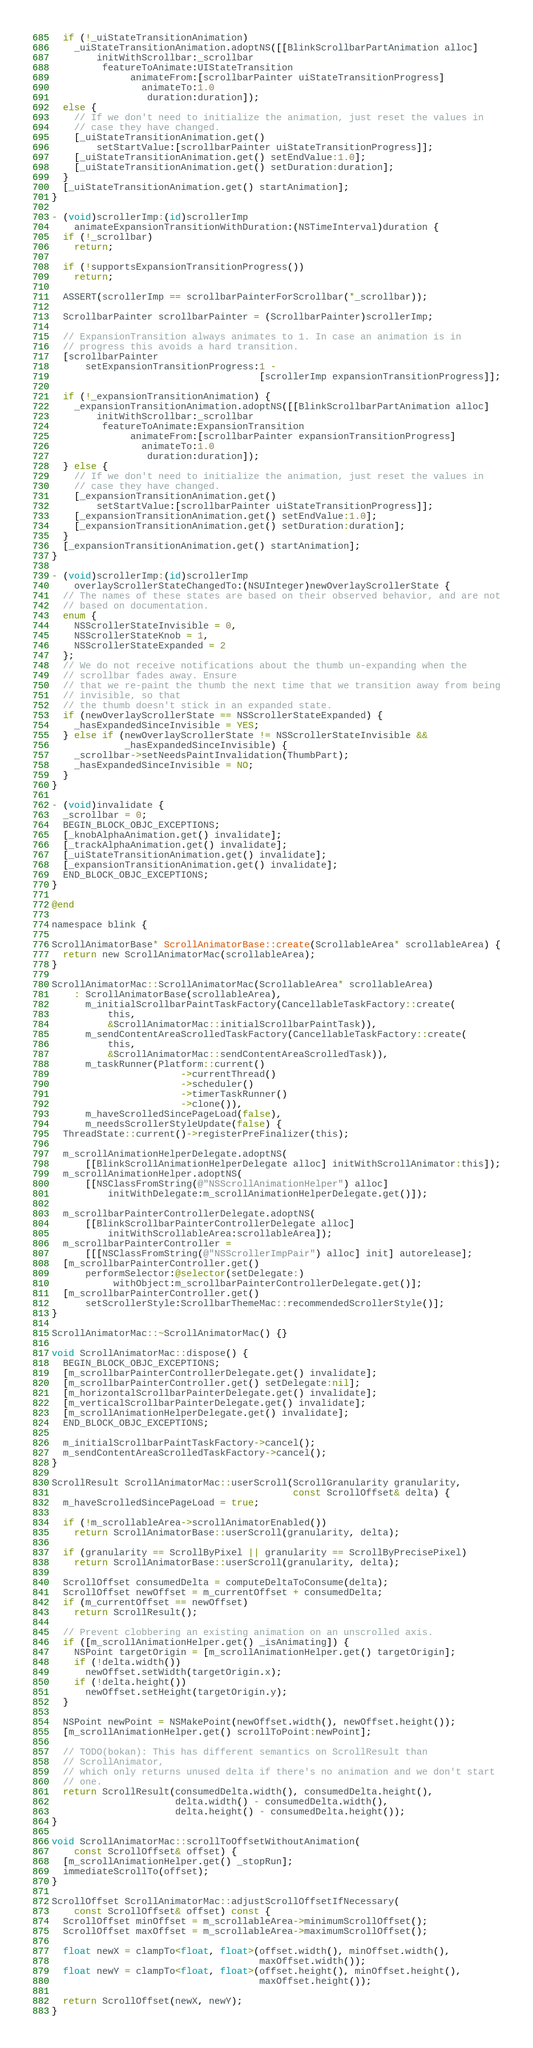<code> <loc_0><loc_0><loc_500><loc_500><_ObjectiveC_>
  if (!_uiStateTransitionAnimation)
    _uiStateTransitionAnimation.adoptNS([[BlinkScrollbarPartAnimation alloc]
        initWithScrollbar:_scrollbar
         featureToAnimate:UIStateTransition
              animateFrom:[scrollbarPainter uiStateTransitionProgress]
                animateTo:1.0
                 duration:duration]);
  else {
    // If we don't need to initialize the animation, just reset the values in
    // case they have changed.
    [_uiStateTransitionAnimation.get()
        setStartValue:[scrollbarPainter uiStateTransitionProgress]];
    [_uiStateTransitionAnimation.get() setEndValue:1.0];
    [_uiStateTransitionAnimation.get() setDuration:duration];
  }
  [_uiStateTransitionAnimation.get() startAnimation];
}

- (void)scrollerImp:(id)scrollerImp
    animateExpansionTransitionWithDuration:(NSTimeInterval)duration {
  if (!_scrollbar)
    return;

  if (!supportsExpansionTransitionProgress())
    return;

  ASSERT(scrollerImp == scrollbarPainterForScrollbar(*_scrollbar));

  ScrollbarPainter scrollbarPainter = (ScrollbarPainter)scrollerImp;

  // ExpansionTransition always animates to 1. In case an animation is in
  // progress this avoids a hard transition.
  [scrollbarPainter
      setExpansionTransitionProgress:1 -
                                     [scrollerImp expansionTransitionProgress]];

  if (!_expansionTransitionAnimation) {
    _expansionTransitionAnimation.adoptNS([[BlinkScrollbarPartAnimation alloc]
        initWithScrollbar:_scrollbar
         featureToAnimate:ExpansionTransition
              animateFrom:[scrollbarPainter expansionTransitionProgress]
                animateTo:1.0
                 duration:duration]);
  } else {
    // If we don't need to initialize the animation, just reset the values in
    // case they have changed.
    [_expansionTransitionAnimation.get()
        setStartValue:[scrollbarPainter uiStateTransitionProgress]];
    [_expansionTransitionAnimation.get() setEndValue:1.0];
    [_expansionTransitionAnimation.get() setDuration:duration];
  }
  [_expansionTransitionAnimation.get() startAnimation];
}

- (void)scrollerImp:(id)scrollerImp
    overlayScrollerStateChangedTo:(NSUInteger)newOverlayScrollerState {
  // The names of these states are based on their observed behavior, and are not
  // based on documentation.
  enum {
    NSScrollerStateInvisible = 0,
    NSScrollerStateKnob = 1,
    NSScrollerStateExpanded = 2
  };
  // We do not receive notifications about the thumb un-expanding when the
  // scrollbar fades away. Ensure
  // that we re-paint the thumb the next time that we transition away from being
  // invisible, so that
  // the thumb doesn't stick in an expanded state.
  if (newOverlayScrollerState == NSScrollerStateExpanded) {
    _hasExpandedSinceInvisible = YES;
  } else if (newOverlayScrollerState != NSScrollerStateInvisible &&
             _hasExpandedSinceInvisible) {
    _scrollbar->setNeedsPaintInvalidation(ThumbPart);
    _hasExpandedSinceInvisible = NO;
  }
}

- (void)invalidate {
  _scrollbar = 0;
  BEGIN_BLOCK_OBJC_EXCEPTIONS;
  [_knobAlphaAnimation.get() invalidate];
  [_trackAlphaAnimation.get() invalidate];
  [_uiStateTransitionAnimation.get() invalidate];
  [_expansionTransitionAnimation.get() invalidate];
  END_BLOCK_OBJC_EXCEPTIONS;
}

@end

namespace blink {

ScrollAnimatorBase* ScrollAnimatorBase::create(ScrollableArea* scrollableArea) {
  return new ScrollAnimatorMac(scrollableArea);
}

ScrollAnimatorMac::ScrollAnimatorMac(ScrollableArea* scrollableArea)
    : ScrollAnimatorBase(scrollableArea),
      m_initialScrollbarPaintTaskFactory(CancellableTaskFactory::create(
          this,
          &ScrollAnimatorMac::initialScrollbarPaintTask)),
      m_sendContentAreaScrolledTaskFactory(CancellableTaskFactory::create(
          this,
          &ScrollAnimatorMac::sendContentAreaScrolledTask)),
      m_taskRunner(Platform::current()
                       ->currentThread()
                       ->scheduler()
                       ->timerTaskRunner()
                       ->clone()),
      m_haveScrolledSincePageLoad(false),
      m_needsScrollerStyleUpdate(false) {
  ThreadState::current()->registerPreFinalizer(this);

  m_scrollAnimationHelperDelegate.adoptNS(
      [[BlinkScrollAnimationHelperDelegate alloc] initWithScrollAnimator:this]);
  m_scrollAnimationHelper.adoptNS(
      [[NSClassFromString(@"NSScrollAnimationHelper") alloc]
          initWithDelegate:m_scrollAnimationHelperDelegate.get()]);

  m_scrollbarPainterControllerDelegate.adoptNS(
      [[BlinkScrollbarPainterControllerDelegate alloc]
          initWithScrollableArea:scrollableArea]);
  m_scrollbarPainterController =
      [[[NSClassFromString(@"NSScrollerImpPair") alloc] init] autorelease];
  [m_scrollbarPainterController.get()
      performSelector:@selector(setDelegate:)
           withObject:m_scrollbarPainterControllerDelegate.get()];
  [m_scrollbarPainterController.get()
      setScrollerStyle:ScrollbarThemeMac::recommendedScrollerStyle()];
}

ScrollAnimatorMac::~ScrollAnimatorMac() {}

void ScrollAnimatorMac::dispose() {
  BEGIN_BLOCK_OBJC_EXCEPTIONS;
  [m_scrollbarPainterControllerDelegate.get() invalidate];
  [m_scrollbarPainterController.get() setDelegate:nil];
  [m_horizontalScrollbarPainterDelegate.get() invalidate];
  [m_verticalScrollbarPainterDelegate.get() invalidate];
  [m_scrollAnimationHelperDelegate.get() invalidate];
  END_BLOCK_OBJC_EXCEPTIONS;

  m_initialScrollbarPaintTaskFactory->cancel();
  m_sendContentAreaScrolledTaskFactory->cancel();
}

ScrollResult ScrollAnimatorMac::userScroll(ScrollGranularity granularity,
                                           const ScrollOffset& delta) {
  m_haveScrolledSincePageLoad = true;

  if (!m_scrollableArea->scrollAnimatorEnabled())
    return ScrollAnimatorBase::userScroll(granularity, delta);

  if (granularity == ScrollByPixel || granularity == ScrollByPrecisePixel)
    return ScrollAnimatorBase::userScroll(granularity, delta);

  ScrollOffset consumedDelta = computeDeltaToConsume(delta);
  ScrollOffset newOffset = m_currentOffset + consumedDelta;
  if (m_currentOffset == newOffset)
    return ScrollResult();

  // Prevent clobbering an existing animation on an unscrolled axis.
  if ([m_scrollAnimationHelper.get() _isAnimating]) {
    NSPoint targetOrigin = [m_scrollAnimationHelper.get() targetOrigin];
    if (!delta.width())
      newOffset.setWidth(targetOrigin.x);
    if (!delta.height())
      newOffset.setHeight(targetOrigin.y);
  }

  NSPoint newPoint = NSMakePoint(newOffset.width(), newOffset.height());
  [m_scrollAnimationHelper.get() scrollToPoint:newPoint];

  // TODO(bokan): This has different semantics on ScrollResult than
  // ScrollAnimator,
  // which only returns unused delta if there's no animation and we don't start
  // one.
  return ScrollResult(consumedDelta.width(), consumedDelta.height(),
                      delta.width() - consumedDelta.width(),
                      delta.height() - consumedDelta.height());
}

void ScrollAnimatorMac::scrollToOffsetWithoutAnimation(
    const ScrollOffset& offset) {
  [m_scrollAnimationHelper.get() _stopRun];
  immediateScrollTo(offset);
}

ScrollOffset ScrollAnimatorMac::adjustScrollOffsetIfNecessary(
    const ScrollOffset& offset) const {
  ScrollOffset minOffset = m_scrollableArea->minimumScrollOffset();
  ScrollOffset maxOffset = m_scrollableArea->maximumScrollOffset();

  float newX = clampTo<float, float>(offset.width(), minOffset.width(),
                                     maxOffset.width());
  float newY = clampTo<float, float>(offset.height(), minOffset.height(),
                                     maxOffset.height());

  return ScrollOffset(newX, newY);
}
</code> 